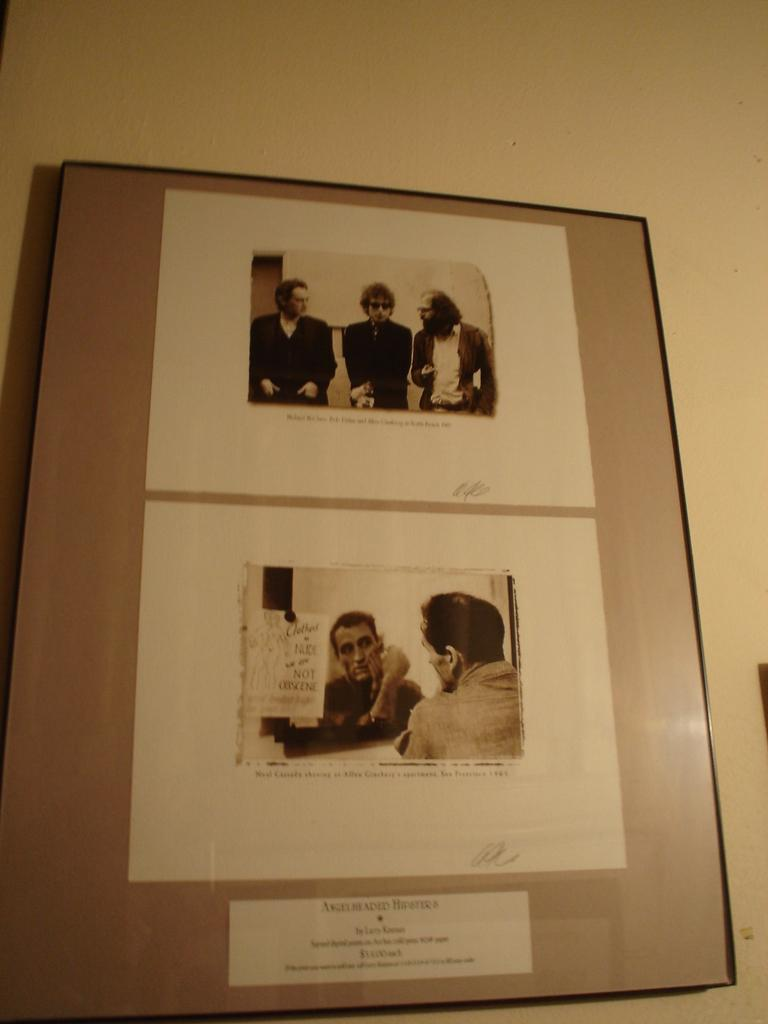What is hanging on the wall in the image? There is a frame on the wall in the image. What can be seen inside the frame? There are people in the frame. What type of ray can be seen swimming in the wilderness in the image? There is no ray or wilderness present in the image; it features a frame with people inside. 